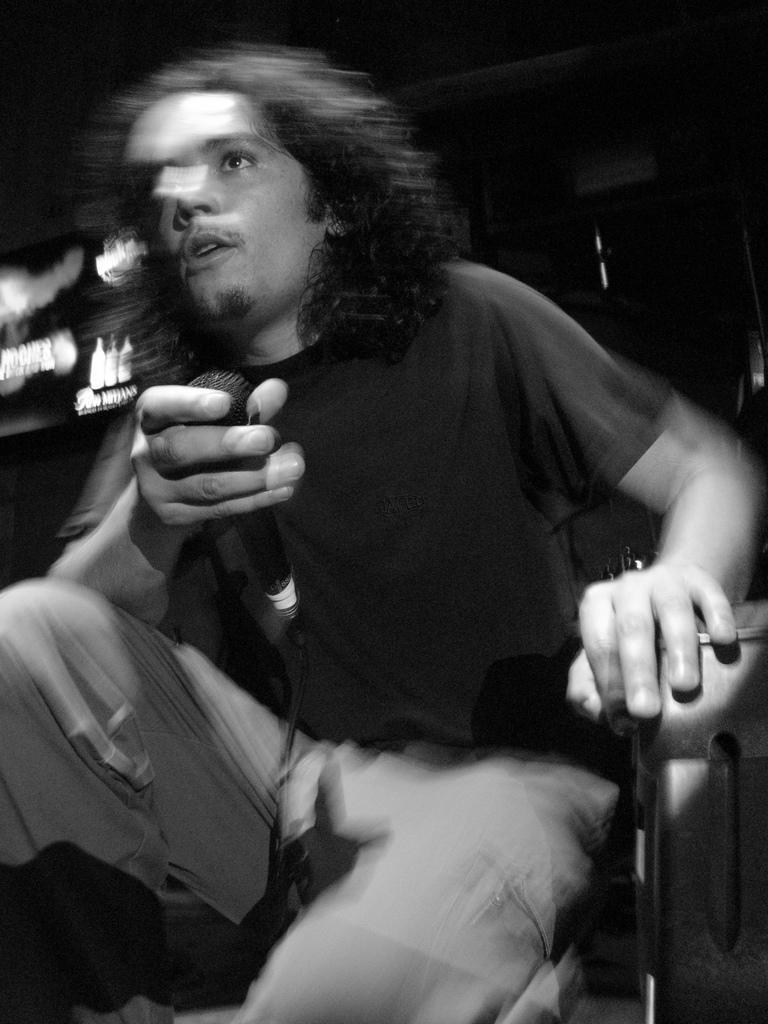Can you describe this image briefly? In this image there is a person sitting on the chair and holding a mike, and there is blur background. 